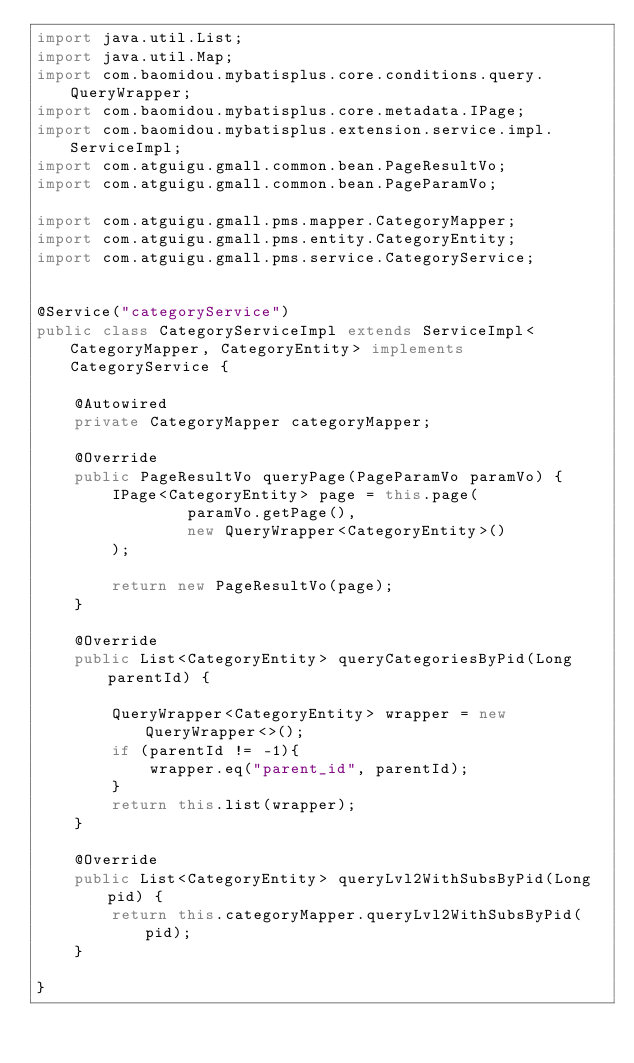Convert code to text. <code><loc_0><loc_0><loc_500><loc_500><_Java_>import java.util.List;
import java.util.Map;
import com.baomidou.mybatisplus.core.conditions.query.QueryWrapper;
import com.baomidou.mybatisplus.core.metadata.IPage;
import com.baomidou.mybatisplus.extension.service.impl.ServiceImpl;
import com.atguigu.gmall.common.bean.PageResultVo;
import com.atguigu.gmall.common.bean.PageParamVo;

import com.atguigu.gmall.pms.mapper.CategoryMapper;
import com.atguigu.gmall.pms.entity.CategoryEntity;
import com.atguigu.gmall.pms.service.CategoryService;


@Service("categoryService")
public class CategoryServiceImpl extends ServiceImpl<CategoryMapper, CategoryEntity> implements CategoryService {

    @Autowired
    private CategoryMapper categoryMapper;

    @Override
    public PageResultVo queryPage(PageParamVo paramVo) {
        IPage<CategoryEntity> page = this.page(
                paramVo.getPage(),
                new QueryWrapper<CategoryEntity>()
        );

        return new PageResultVo(page);
    }

    @Override
    public List<CategoryEntity> queryCategoriesByPid(Long parentId) {

        QueryWrapper<CategoryEntity> wrapper = new QueryWrapper<>();
        if (parentId != -1){
            wrapper.eq("parent_id", parentId);
        }
        return this.list(wrapper);
    }

    @Override
    public List<CategoryEntity> queryLvl2WithSubsByPid(Long pid) {
        return this.categoryMapper.queryLvl2WithSubsByPid(pid);
    }

}</code> 